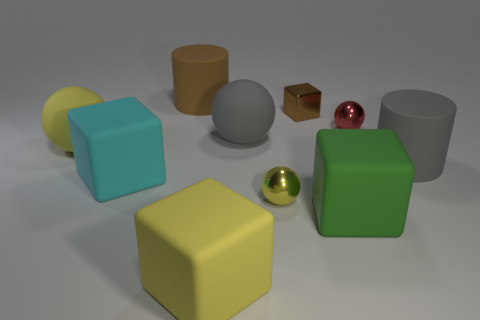What material is the red object that is the same size as the yellow metallic ball?
Make the answer very short. Metal. What is the material of the cube that is behind the gray rubber object on the right side of the large gray matte thing behind the big gray cylinder?
Make the answer very short. Metal. What color is the small metal cube?
Your response must be concise. Brown. What number of tiny objects are either matte objects or gray matte balls?
Provide a short and direct response. 0. There is a cylinder that is the same color as the metal cube; what is its material?
Your answer should be compact. Rubber. Does the gray object that is right of the small brown shiny block have the same material as the gray thing that is on the left side of the brown block?
Offer a terse response. Yes. Are any large metallic cubes visible?
Your answer should be very brief. No. Is the number of large cyan matte things to the right of the big green thing greater than the number of tiny brown shiny blocks in front of the brown metallic thing?
Keep it short and to the point. No. What is the material of the brown thing that is the same shape as the green thing?
Your answer should be very brief. Metal. Is there anything else that has the same size as the green cube?
Make the answer very short. Yes. 